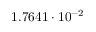Convert formula to latex. <formula><loc_0><loc_0><loc_500><loc_500>1 . 7 6 4 1 \cdot 1 0 ^ { - 2 }</formula> 